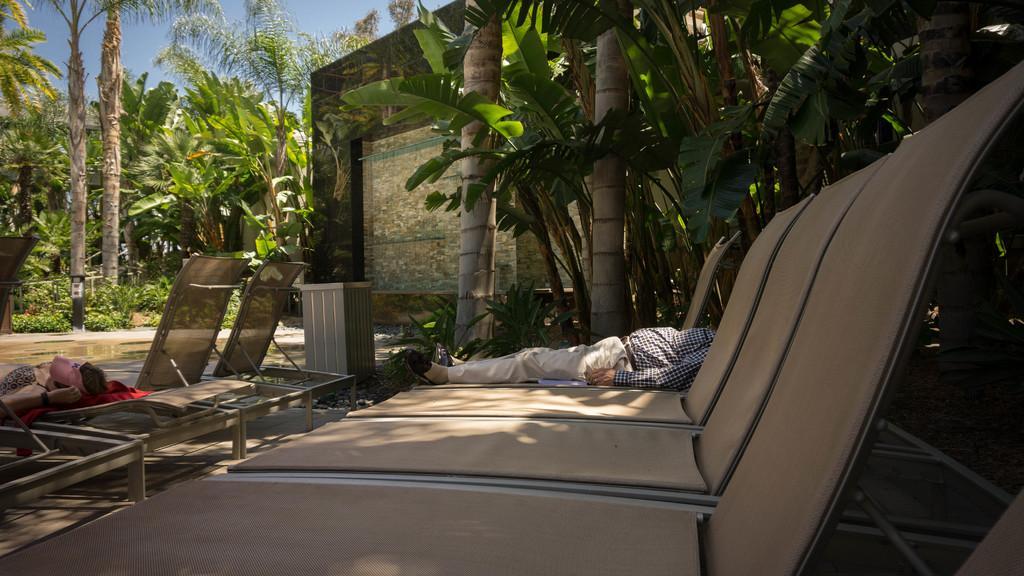In one or two sentences, can you explain what this image depicts? In this image there are benches on which there are people sleeping, beside that there is a buildings and trees. 